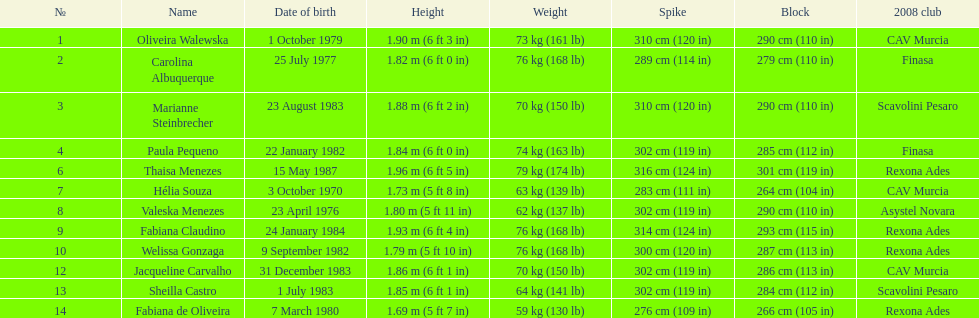Who is the next tallest player after thaisa menezes? Fabiana Claudino. 